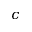<formula> <loc_0><loc_0><loc_500><loc_500>c</formula> 